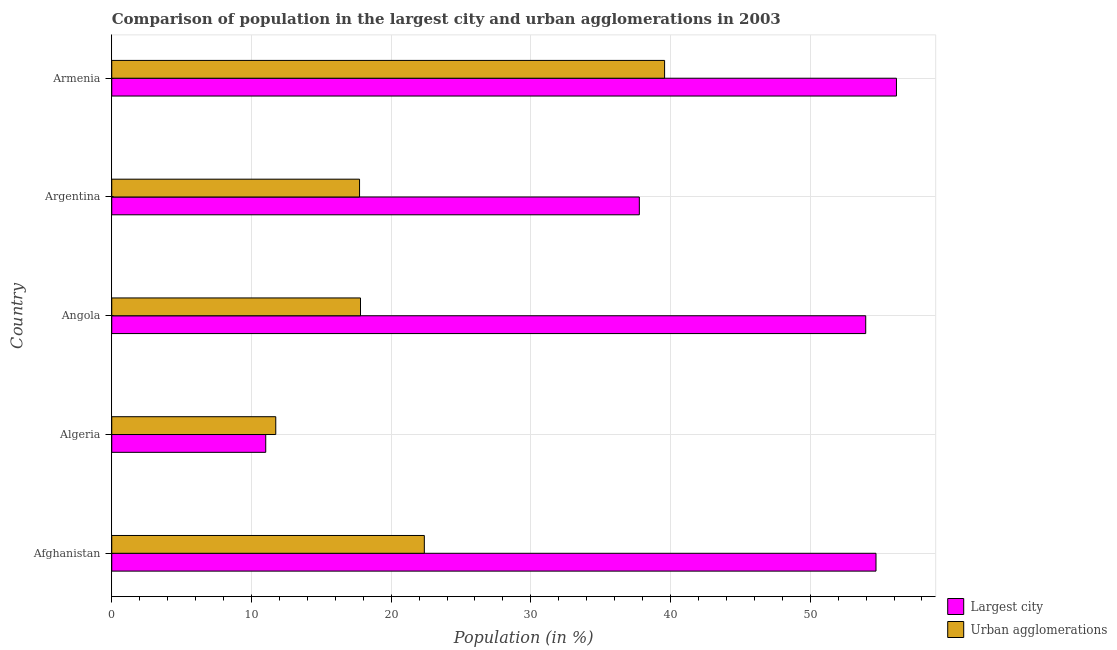How many different coloured bars are there?
Give a very brief answer. 2. How many bars are there on the 1st tick from the top?
Provide a succinct answer. 2. How many bars are there on the 1st tick from the bottom?
Give a very brief answer. 2. What is the label of the 4th group of bars from the top?
Give a very brief answer. Algeria. What is the population in the largest city in Armenia?
Give a very brief answer. 56.17. Across all countries, what is the maximum population in urban agglomerations?
Your response must be concise. 39.58. Across all countries, what is the minimum population in the largest city?
Ensure brevity in your answer.  11.02. In which country was the population in the largest city maximum?
Offer a terse response. Armenia. In which country was the population in urban agglomerations minimum?
Your answer should be very brief. Algeria. What is the total population in the largest city in the graph?
Make the answer very short. 213.65. What is the difference between the population in urban agglomerations in Algeria and that in Angola?
Ensure brevity in your answer.  -6.07. What is the difference between the population in urban agglomerations in Armenia and the population in the largest city in Afghanistan?
Provide a short and direct response. -15.13. What is the average population in the largest city per country?
Your response must be concise. 42.73. What is the difference between the population in urban agglomerations and population in the largest city in Algeria?
Provide a succinct answer. 0.72. In how many countries, is the population in urban agglomerations greater than 16 %?
Your response must be concise. 4. What is the ratio of the population in urban agglomerations in Algeria to that in Argentina?
Keep it short and to the point. 0.66. What is the difference between the highest and the second highest population in urban agglomerations?
Your response must be concise. 17.2. What is the difference between the highest and the lowest population in the largest city?
Make the answer very short. 45.15. What does the 2nd bar from the top in Afghanistan represents?
Provide a succinct answer. Largest city. What does the 1st bar from the bottom in Angola represents?
Make the answer very short. Largest city. How many bars are there?
Your answer should be compact. 10. What is the difference between two consecutive major ticks on the X-axis?
Give a very brief answer. 10. Are the values on the major ticks of X-axis written in scientific E-notation?
Ensure brevity in your answer.  No. Does the graph contain any zero values?
Your answer should be very brief. No. Does the graph contain grids?
Provide a succinct answer. Yes. Where does the legend appear in the graph?
Make the answer very short. Bottom right. How many legend labels are there?
Give a very brief answer. 2. What is the title of the graph?
Make the answer very short. Comparison of population in the largest city and urban agglomerations in 2003. Does "Underweight" appear as one of the legend labels in the graph?
Give a very brief answer. No. What is the label or title of the X-axis?
Your answer should be very brief. Population (in %). What is the Population (in %) of Largest city in Afghanistan?
Offer a terse response. 54.71. What is the Population (in %) in Urban agglomerations in Afghanistan?
Give a very brief answer. 22.38. What is the Population (in %) of Largest city in Algeria?
Offer a terse response. 11.02. What is the Population (in %) in Urban agglomerations in Algeria?
Offer a very short reply. 11.74. What is the Population (in %) in Largest city in Angola?
Provide a short and direct response. 53.97. What is the Population (in %) of Urban agglomerations in Angola?
Make the answer very short. 17.81. What is the Population (in %) in Largest city in Argentina?
Provide a succinct answer. 37.77. What is the Population (in %) of Urban agglomerations in Argentina?
Give a very brief answer. 17.74. What is the Population (in %) in Largest city in Armenia?
Your response must be concise. 56.17. What is the Population (in %) in Urban agglomerations in Armenia?
Make the answer very short. 39.58. Across all countries, what is the maximum Population (in %) of Largest city?
Your answer should be very brief. 56.17. Across all countries, what is the maximum Population (in %) in Urban agglomerations?
Give a very brief answer. 39.58. Across all countries, what is the minimum Population (in %) of Largest city?
Offer a terse response. 11.02. Across all countries, what is the minimum Population (in %) in Urban agglomerations?
Your response must be concise. 11.74. What is the total Population (in %) of Largest city in the graph?
Your response must be concise. 213.65. What is the total Population (in %) of Urban agglomerations in the graph?
Keep it short and to the point. 109.24. What is the difference between the Population (in %) in Largest city in Afghanistan and that in Algeria?
Your response must be concise. 43.69. What is the difference between the Population (in %) in Urban agglomerations in Afghanistan and that in Algeria?
Provide a succinct answer. 10.64. What is the difference between the Population (in %) of Largest city in Afghanistan and that in Angola?
Your response must be concise. 0.74. What is the difference between the Population (in %) of Urban agglomerations in Afghanistan and that in Angola?
Offer a very short reply. 4.57. What is the difference between the Population (in %) of Largest city in Afghanistan and that in Argentina?
Make the answer very short. 16.94. What is the difference between the Population (in %) in Urban agglomerations in Afghanistan and that in Argentina?
Give a very brief answer. 4.64. What is the difference between the Population (in %) of Largest city in Afghanistan and that in Armenia?
Provide a short and direct response. -1.47. What is the difference between the Population (in %) of Urban agglomerations in Afghanistan and that in Armenia?
Keep it short and to the point. -17.2. What is the difference between the Population (in %) in Largest city in Algeria and that in Angola?
Your response must be concise. -42.95. What is the difference between the Population (in %) of Urban agglomerations in Algeria and that in Angola?
Offer a very short reply. -6.07. What is the difference between the Population (in %) of Largest city in Algeria and that in Argentina?
Provide a succinct answer. -26.74. What is the difference between the Population (in %) in Urban agglomerations in Algeria and that in Argentina?
Ensure brevity in your answer.  -6. What is the difference between the Population (in %) of Largest city in Algeria and that in Armenia?
Your answer should be compact. -45.15. What is the difference between the Population (in %) in Urban agglomerations in Algeria and that in Armenia?
Keep it short and to the point. -27.83. What is the difference between the Population (in %) in Largest city in Angola and that in Argentina?
Ensure brevity in your answer.  16.21. What is the difference between the Population (in %) of Urban agglomerations in Angola and that in Argentina?
Make the answer very short. 0.07. What is the difference between the Population (in %) in Largest city in Angola and that in Armenia?
Ensure brevity in your answer.  -2.2. What is the difference between the Population (in %) of Urban agglomerations in Angola and that in Armenia?
Provide a succinct answer. -21.77. What is the difference between the Population (in %) in Largest city in Argentina and that in Armenia?
Make the answer very short. -18.41. What is the difference between the Population (in %) of Urban agglomerations in Argentina and that in Armenia?
Offer a very short reply. -21.84. What is the difference between the Population (in %) in Largest city in Afghanistan and the Population (in %) in Urban agglomerations in Algeria?
Offer a very short reply. 42.97. What is the difference between the Population (in %) of Largest city in Afghanistan and the Population (in %) of Urban agglomerations in Angola?
Provide a short and direct response. 36.9. What is the difference between the Population (in %) of Largest city in Afghanistan and the Population (in %) of Urban agglomerations in Argentina?
Make the answer very short. 36.97. What is the difference between the Population (in %) of Largest city in Afghanistan and the Population (in %) of Urban agglomerations in Armenia?
Offer a very short reply. 15.13. What is the difference between the Population (in %) of Largest city in Algeria and the Population (in %) of Urban agglomerations in Angola?
Offer a very short reply. -6.78. What is the difference between the Population (in %) of Largest city in Algeria and the Population (in %) of Urban agglomerations in Argentina?
Provide a succinct answer. -6.72. What is the difference between the Population (in %) of Largest city in Algeria and the Population (in %) of Urban agglomerations in Armenia?
Keep it short and to the point. -28.55. What is the difference between the Population (in %) of Largest city in Angola and the Population (in %) of Urban agglomerations in Argentina?
Give a very brief answer. 36.23. What is the difference between the Population (in %) in Largest city in Angola and the Population (in %) in Urban agglomerations in Armenia?
Provide a succinct answer. 14.4. What is the difference between the Population (in %) of Largest city in Argentina and the Population (in %) of Urban agglomerations in Armenia?
Keep it short and to the point. -1.81. What is the average Population (in %) in Largest city per country?
Your answer should be compact. 42.73. What is the average Population (in %) of Urban agglomerations per country?
Offer a very short reply. 21.85. What is the difference between the Population (in %) in Largest city and Population (in %) in Urban agglomerations in Afghanistan?
Ensure brevity in your answer.  32.33. What is the difference between the Population (in %) of Largest city and Population (in %) of Urban agglomerations in Algeria?
Your answer should be compact. -0.72. What is the difference between the Population (in %) in Largest city and Population (in %) in Urban agglomerations in Angola?
Keep it short and to the point. 36.17. What is the difference between the Population (in %) of Largest city and Population (in %) of Urban agglomerations in Argentina?
Give a very brief answer. 20.03. What is the difference between the Population (in %) in Largest city and Population (in %) in Urban agglomerations in Armenia?
Make the answer very short. 16.6. What is the ratio of the Population (in %) of Largest city in Afghanistan to that in Algeria?
Ensure brevity in your answer.  4.96. What is the ratio of the Population (in %) of Urban agglomerations in Afghanistan to that in Algeria?
Make the answer very short. 1.91. What is the ratio of the Population (in %) of Largest city in Afghanistan to that in Angola?
Offer a terse response. 1.01. What is the ratio of the Population (in %) in Urban agglomerations in Afghanistan to that in Angola?
Offer a very short reply. 1.26. What is the ratio of the Population (in %) of Largest city in Afghanistan to that in Argentina?
Provide a short and direct response. 1.45. What is the ratio of the Population (in %) in Urban agglomerations in Afghanistan to that in Argentina?
Offer a terse response. 1.26. What is the ratio of the Population (in %) of Largest city in Afghanistan to that in Armenia?
Make the answer very short. 0.97. What is the ratio of the Population (in %) in Urban agglomerations in Afghanistan to that in Armenia?
Ensure brevity in your answer.  0.57. What is the ratio of the Population (in %) of Largest city in Algeria to that in Angola?
Ensure brevity in your answer.  0.2. What is the ratio of the Population (in %) in Urban agglomerations in Algeria to that in Angola?
Give a very brief answer. 0.66. What is the ratio of the Population (in %) of Largest city in Algeria to that in Argentina?
Provide a succinct answer. 0.29. What is the ratio of the Population (in %) of Urban agglomerations in Algeria to that in Argentina?
Make the answer very short. 0.66. What is the ratio of the Population (in %) of Largest city in Algeria to that in Armenia?
Offer a very short reply. 0.2. What is the ratio of the Population (in %) in Urban agglomerations in Algeria to that in Armenia?
Give a very brief answer. 0.3. What is the ratio of the Population (in %) of Largest city in Angola to that in Argentina?
Ensure brevity in your answer.  1.43. What is the ratio of the Population (in %) of Largest city in Angola to that in Armenia?
Your answer should be very brief. 0.96. What is the ratio of the Population (in %) in Urban agglomerations in Angola to that in Armenia?
Offer a very short reply. 0.45. What is the ratio of the Population (in %) in Largest city in Argentina to that in Armenia?
Keep it short and to the point. 0.67. What is the ratio of the Population (in %) of Urban agglomerations in Argentina to that in Armenia?
Offer a very short reply. 0.45. What is the difference between the highest and the second highest Population (in %) of Largest city?
Offer a very short reply. 1.47. What is the difference between the highest and the second highest Population (in %) of Urban agglomerations?
Your answer should be very brief. 17.2. What is the difference between the highest and the lowest Population (in %) of Largest city?
Provide a short and direct response. 45.15. What is the difference between the highest and the lowest Population (in %) in Urban agglomerations?
Offer a terse response. 27.83. 